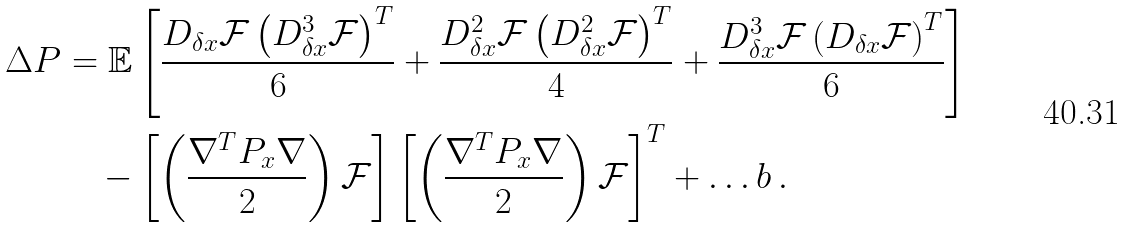<formula> <loc_0><loc_0><loc_500><loc_500>\Delta P & = \mathbb { E } \left [ \frac { D _ { \delta x } \mathcal { F } \left ( D _ { \delta x } ^ { 3 } \mathcal { F } \right ) ^ { T } } { 6 } + \frac { D _ { \delta x } ^ { 2 } \mathcal { F } \left ( D _ { \delta x } ^ { 2 } \mathcal { F } \right ) ^ { T } } { 4 } + \frac { D _ { \delta x } ^ { 3 } \mathcal { F } \left ( D _ { \delta x } \mathcal { F } \right ) ^ { T } } { 6 } \right ] \\ & \quad - \left [ \left ( \frac { \nabla ^ { T } P _ { x } \nabla } { 2 } \right ) \mathcal { F } \right ] \left [ \left ( \frac { \nabla ^ { T } P _ { x } \nabla } { 2 } \right ) \mathcal { F } \right ] ^ { T } + \dots b \, .</formula> 